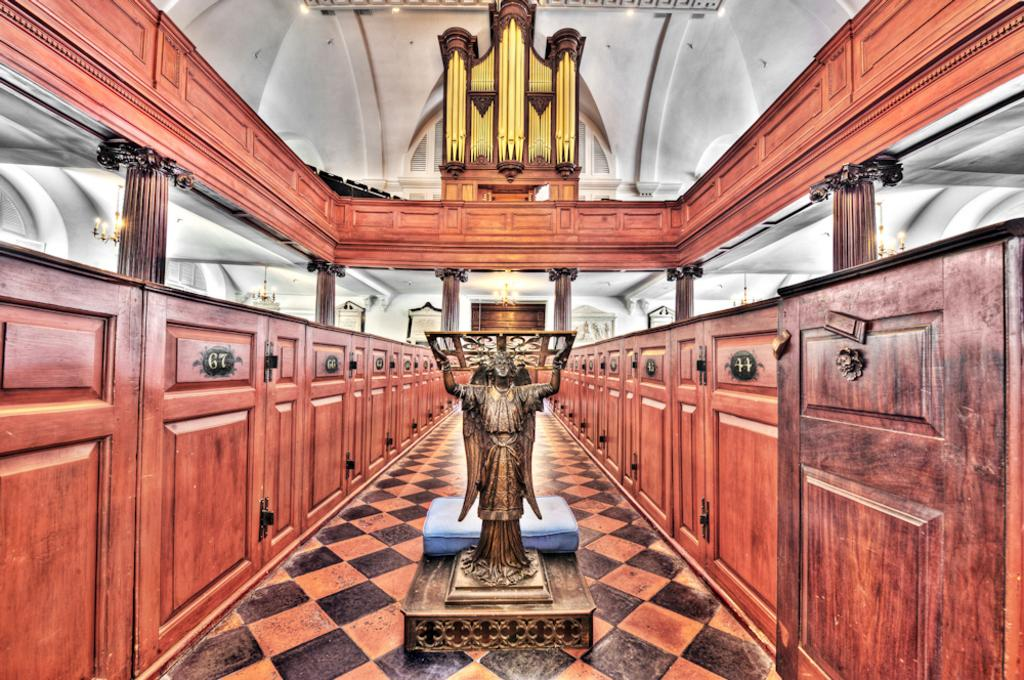What is the main subject in the image? There is a statue in the image. What can be seen on either side of the statue? There are wooden cupboards on either side of the statue. What else can be seen in the background of the image? There are other objects visible in the background of the image. What language is the statue speaking in the image? The statue is not speaking in the image, as it is a non-living object. 